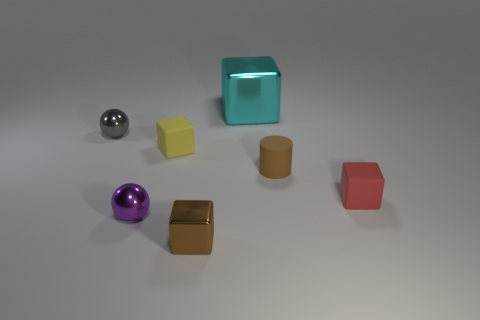Can you describe the color variety among the objects shown? Certainly! The image displays a variety of colors, including a shiny silver sphere, a glossy purple sphere, a translucent teal cube, a matte yellow cube, a brown cylindrical object, and a matte red cube. The range of colors suggests a vibrant and diverse selection, possibly for a color-recognition task or to highlight differences in materials and finishes. 